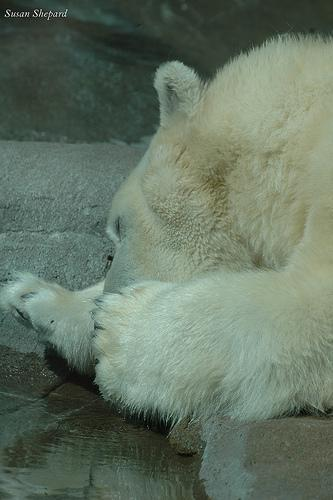Question: what is the polar bear doing?
Choices:
A. Growling.
B. Playing.
C. Sleeping.
D. Running.
Answer with the letter. Answer: C Question: why is the polar bear laying down?
Choices:
A. To eat.
B. He is playing.
C. To rest.
D. To stalk prey.
Answer with the letter. Answer: C Question: what color are the rocks?
Choices:
A. Gray.
B. White.
C. Brown.
D. Black.
Answer with the letter. Answer: A Question: what animal is in the picture?
Choices:
A. Zebra.
B. Giraffe.
C. Elephant.
D. Polar bear.
Answer with the letter. Answer: D Question: where is the polar bear's left foot?
Choices:
A. On a rock.
B. On its face.
C. In the grass.
D. In the water.
Answer with the letter. Answer: B 